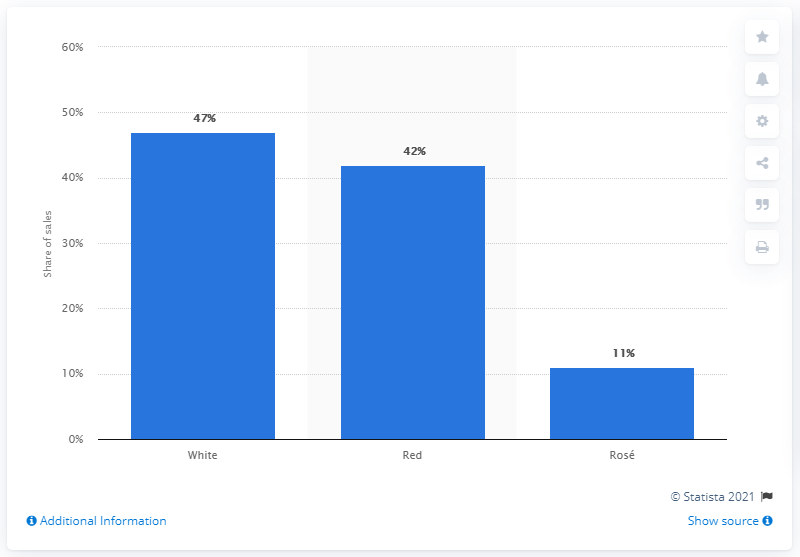Mention a couple of crucial points in this snapshot. In 2016, white wine accounted for approximately 47% of all wine sold in the United States. 